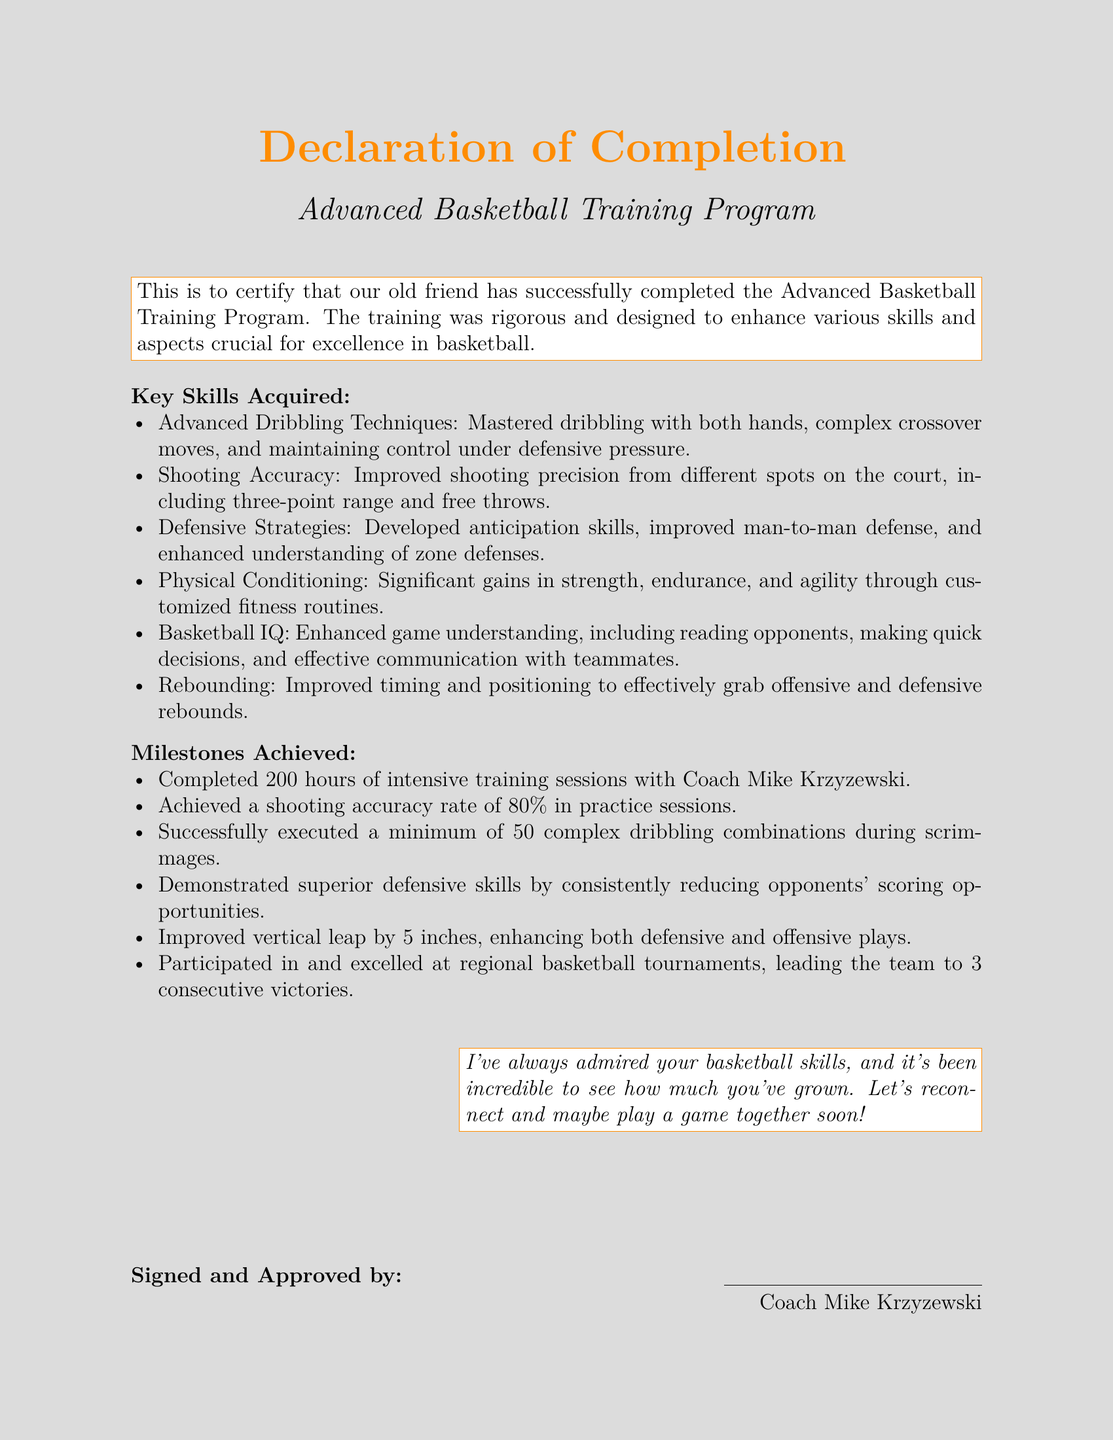What is the title of the program? The title of the program is stated in the document as part of the header section.
Answer: Advanced Basketball Training Program Who is the signatory of the document? The document specifies the signatory at the bottom as the person who certifies the completion.
Answer: Coach Mike Krzyzewski How many hours of training were completed? The document lists a specific number of hours completed in training sessions as one of the milestones.
Answer: 200 hours What shooting accuracy rate was achieved during practice sessions? The document provides the exact rate achieved as part of the milestones section.
Answer: 80% What skill is associated with enhancing game understanding? The document categorizes Basketball IQ as a key skill acquired in the program.
Answer: Basketball IQ How much did the vertical leap improve? The milestone section of the document mentions the specific amount of vertical leap improvement.
Answer: 5 inches What was one of the key defensive strategies developed? The document lists improved man-to-man defense as a specific strategy acquired.
Answer: Man-to-man defense How many consecutive victories did the team achieve in regional tournaments? The document specifies the number of victories achieved during tournaments as part of the milestones.
Answer: 3 consecutive victories 